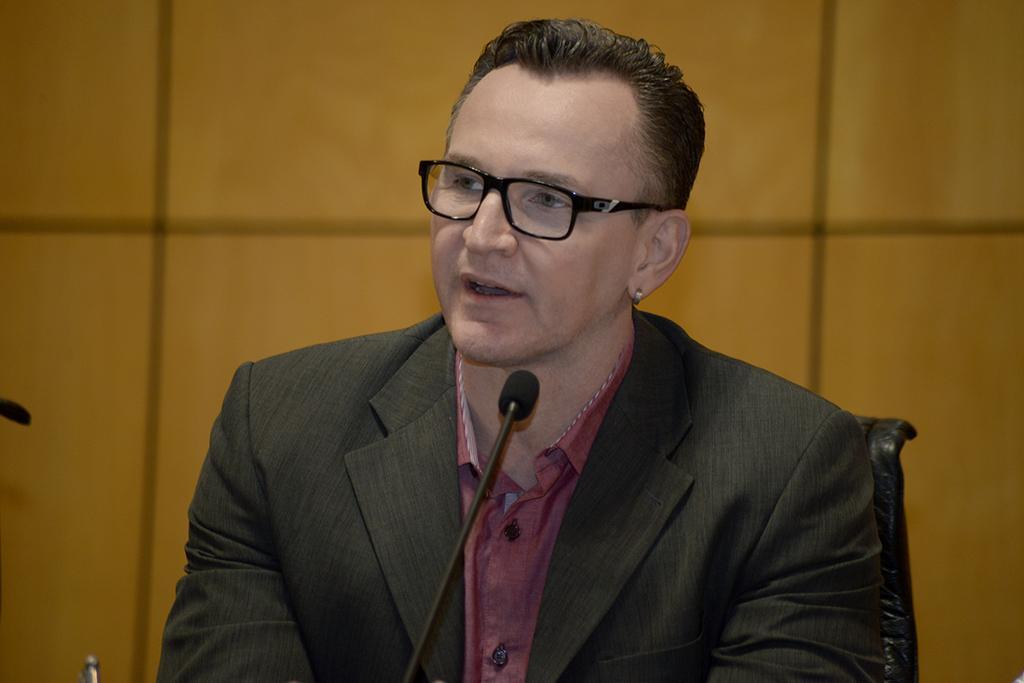In one or two sentences, can you explain what this image depicts? In this image, I can see a man sitting. He wore a suit, shirt and a spectacle. This is a mike. In the background, that looks like a wall. 